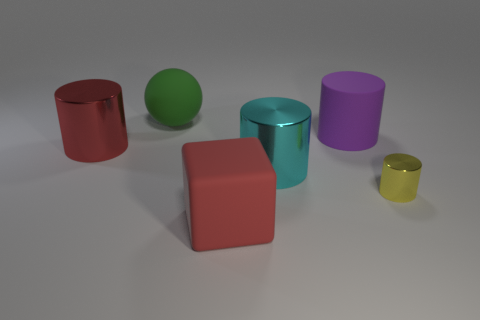Are there any other things that have the same size as the yellow thing?
Your response must be concise. No. How big is the shiny cylinder on the left side of the block?
Provide a short and direct response. Large. What number of tiny gray metal things are the same shape as the purple thing?
Your answer should be compact. 0. There is a red thing that is the same material as the cyan cylinder; what is its size?
Make the answer very short. Large. There is a big rubber object that is in front of the big red object behind the tiny yellow shiny cylinder; is there a yellow cylinder to the left of it?
Ensure brevity in your answer.  No. Does the rubber thing that is in front of the matte cylinder have the same size as the small yellow metallic cylinder?
Offer a very short reply. No. How many matte things are the same size as the cyan metallic cylinder?
Your answer should be compact. 3. What is the size of the thing that is the same color as the cube?
Make the answer very short. Large. Is the color of the rubber cube the same as the tiny metallic cylinder?
Ensure brevity in your answer.  No. The large green rubber object has what shape?
Keep it short and to the point. Sphere. 